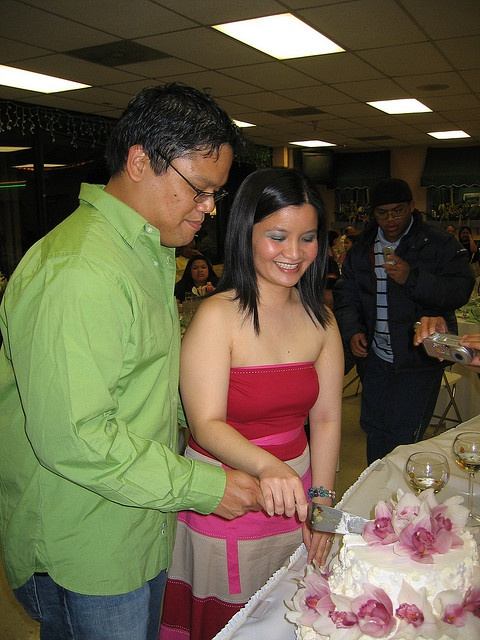Describe the objects in this image and their specific colors. I can see people in black, lightgreen, and olive tones, people in black, gray, and tan tones, people in black, gray, maroon, and tan tones, cake in black, lightgray, darkgray, and brown tones, and wine glass in black, gray, and olive tones in this image. 